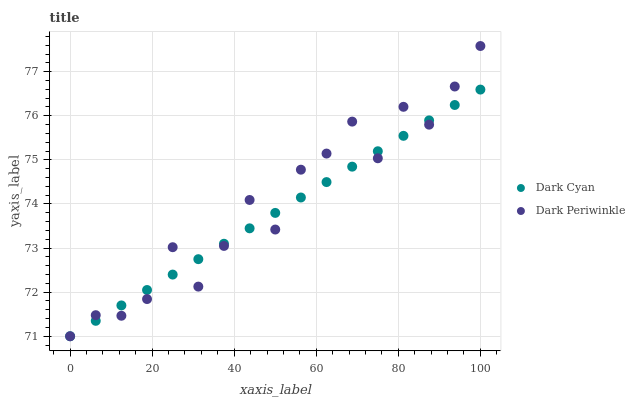Does Dark Cyan have the minimum area under the curve?
Answer yes or no. Yes. Does Dark Periwinkle have the maximum area under the curve?
Answer yes or no. Yes. Does Dark Periwinkle have the minimum area under the curve?
Answer yes or no. No. Is Dark Cyan the smoothest?
Answer yes or no. Yes. Is Dark Periwinkle the roughest?
Answer yes or no. Yes. Is Dark Periwinkle the smoothest?
Answer yes or no. No. Does Dark Cyan have the lowest value?
Answer yes or no. Yes. Does Dark Periwinkle have the highest value?
Answer yes or no. Yes. Does Dark Periwinkle intersect Dark Cyan?
Answer yes or no. Yes. Is Dark Periwinkle less than Dark Cyan?
Answer yes or no. No. Is Dark Periwinkle greater than Dark Cyan?
Answer yes or no. No. 